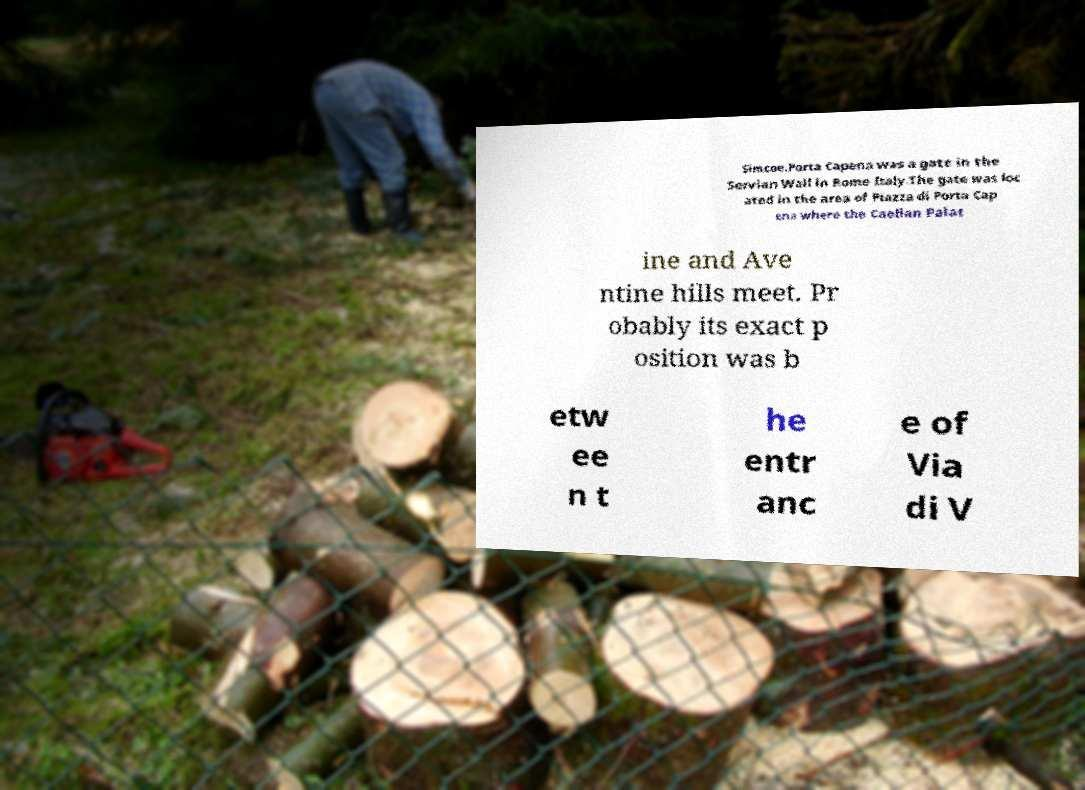Can you read and provide the text displayed in the image?This photo seems to have some interesting text. Can you extract and type it out for me? Simcoe.Porta Capena was a gate in the Servian Wall in Rome Italy.The gate was loc ated in the area of Piazza di Porta Cap ena where the Caelian Palat ine and Ave ntine hills meet. Pr obably its exact p osition was b etw ee n t he entr anc e of Via di V 